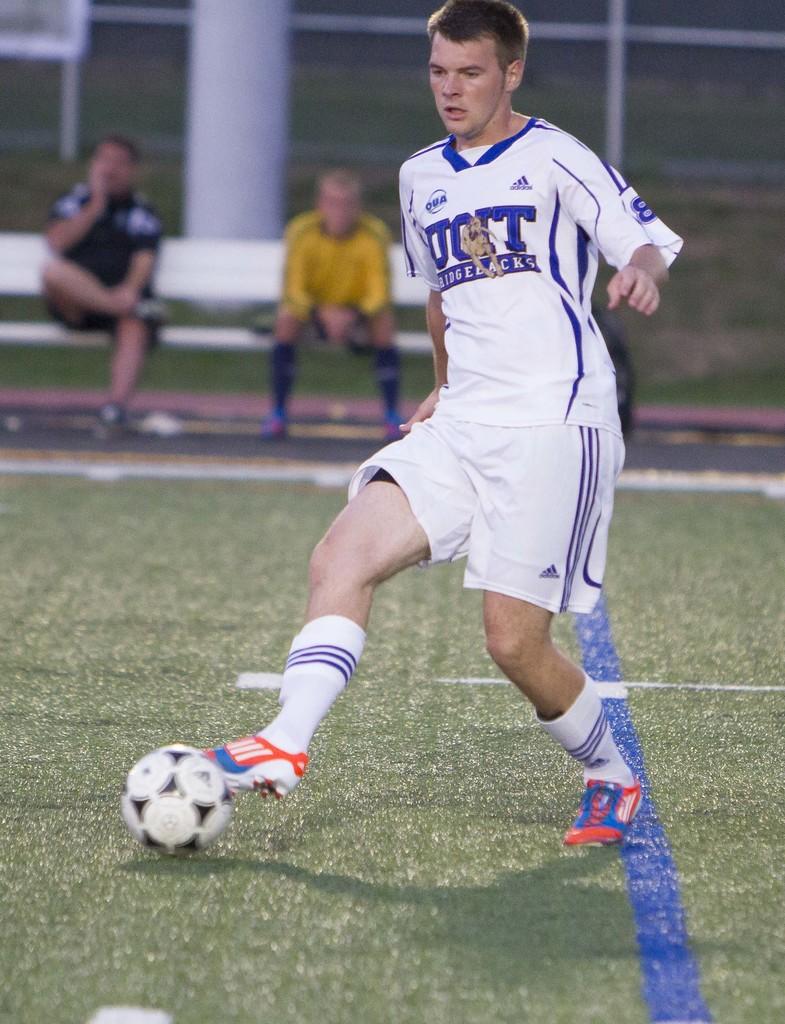What school is on the jersey?
Offer a terse response. Uoit. 